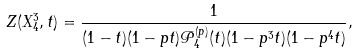Convert formula to latex. <formula><loc_0><loc_0><loc_500><loc_500>Z ( X _ { 4 } ^ { 3 } , t ) = \frac { 1 } { ( 1 - t ) ( 1 - p t ) { \mathcal { P } } _ { 4 } ^ { ( p ) } ( t ) ( 1 - p ^ { 3 } t ) ( 1 - p ^ { 4 } t ) } ,</formula> 